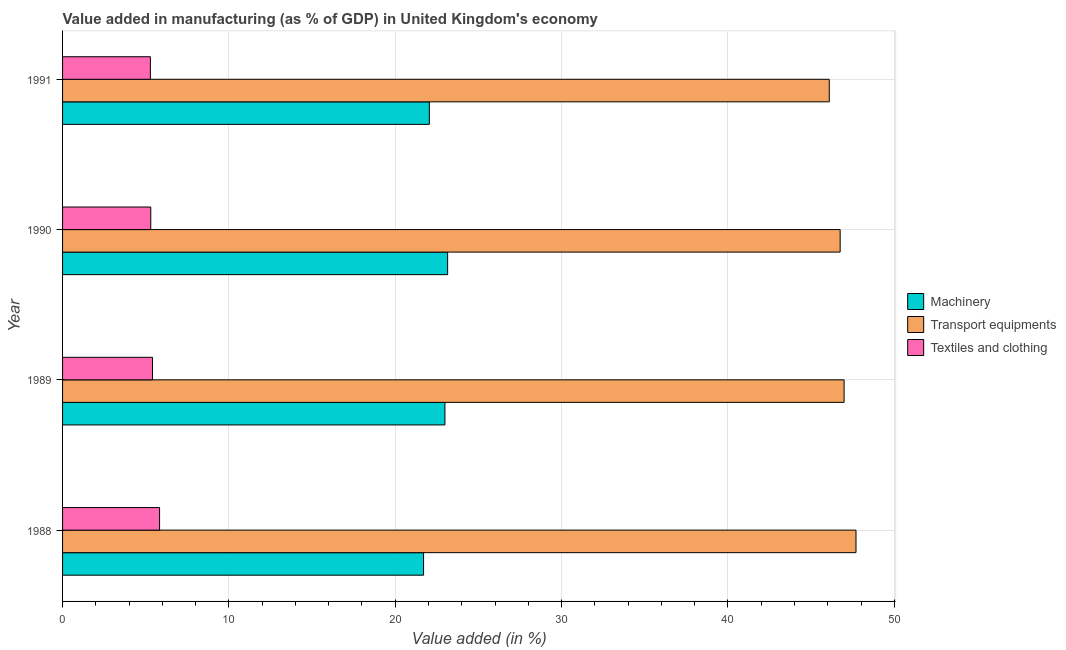How many groups of bars are there?
Offer a very short reply. 4. Are the number of bars on each tick of the Y-axis equal?
Give a very brief answer. Yes. How many bars are there on the 4th tick from the bottom?
Provide a short and direct response. 3. What is the value added in manufacturing machinery in 1988?
Your response must be concise. 21.7. Across all years, what is the maximum value added in manufacturing textile and clothing?
Make the answer very short. 5.83. Across all years, what is the minimum value added in manufacturing textile and clothing?
Offer a very short reply. 5.28. What is the total value added in manufacturing textile and clothing in the graph?
Your response must be concise. 21.82. What is the difference between the value added in manufacturing textile and clothing in 1990 and that in 1991?
Your response must be concise. 0.02. What is the difference between the value added in manufacturing transport equipments in 1991 and the value added in manufacturing machinery in 1988?
Provide a succinct answer. 24.39. What is the average value added in manufacturing machinery per year?
Provide a short and direct response. 22.47. In the year 1988, what is the difference between the value added in manufacturing machinery and value added in manufacturing transport equipments?
Provide a succinct answer. -26. What is the ratio of the value added in manufacturing textile and clothing in 1988 to that in 1991?
Your response must be concise. 1.1. Is the difference between the value added in manufacturing machinery in 1989 and 1990 greater than the difference between the value added in manufacturing transport equipments in 1989 and 1990?
Provide a short and direct response. No. What is the difference between the highest and the second highest value added in manufacturing machinery?
Give a very brief answer. 0.16. What is the difference between the highest and the lowest value added in manufacturing machinery?
Keep it short and to the point. 1.45. Is the sum of the value added in manufacturing textile and clothing in 1988 and 1989 greater than the maximum value added in manufacturing transport equipments across all years?
Provide a succinct answer. No. What does the 3rd bar from the top in 1990 represents?
Ensure brevity in your answer.  Machinery. What does the 2nd bar from the bottom in 1989 represents?
Provide a succinct answer. Transport equipments. How many legend labels are there?
Your answer should be very brief. 3. How are the legend labels stacked?
Ensure brevity in your answer.  Vertical. What is the title of the graph?
Ensure brevity in your answer.  Value added in manufacturing (as % of GDP) in United Kingdom's economy. Does "Taxes on income" appear as one of the legend labels in the graph?
Offer a very short reply. No. What is the label or title of the X-axis?
Make the answer very short. Value added (in %). What is the Value added (in %) of Machinery in 1988?
Offer a very short reply. 21.7. What is the Value added (in %) of Transport equipments in 1988?
Offer a very short reply. 47.7. What is the Value added (in %) in Textiles and clothing in 1988?
Provide a short and direct response. 5.83. What is the Value added (in %) of Machinery in 1989?
Your answer should be very brief. 22.99. What is the Value added (in %) in Transport equipments in 1989?
Give a very brief answer. 46.98. What is the Value added (in %) of Textiles and clothing in 1989?
Your answer should be compact. 5.41. What is the Value added (in %) of Machinery in 1990?
Your answer should be compact. 23.15. What is the Value added (in %) in Transport equipments in 1990?
Provide a succinct answer. 46.75. What is the Value added (in %) in Textiles and clothing in 1990?
Offer a terse response. 5.3. What is the Value added (in %) in Machinery in 1991?
Provide a short and direct response. 22.05. What is the Value added (in %) in Transport equipments in 1991?
Offer a very short reply. 46.09. What is the Value added (in %) of Textiles and clothing in 1991?
Provide a succinct answer. 5.28. Across all years, what is the maximum Value added (in %) of Machinery?
Keep it short and to the point. 23.15. Across all years, what is the maximum Value added (in %) in Transport equipments?
Make the answer very short. 47.7. Across all years, what is the maximum Value added (in %) in Textiles and clothing?
Your answer should be very brief. 5.83. Across all years, what is the minimum Value added (in %) of Machinery?
Your answer should be compact. 21.7. Across all years, what is the minimum Value added (in %) in Transport equipments?
Your answer should be very brief. 46.09. Across all years, what is the minimum Value added (in %) in Textiles and clothing?
Ensure brevity in your answer.  5.28. What is the total Value added (in %) of Machinery in the graph?
Ensure brevity in your answer.  89.89. What is the total Value added (in %) in Transport equipments in the graph?
Your response must be concise. 187.52. What is the total Value added (in %) in Textiles and clothing in the graph?
Give a very brief answer. 21.82. What is the difference between the Value added (in %) of Machinery in 1988 and that in 1989?
Provide a short and direct response. -1.28. What is the difference between the Value added (in %) of Transport equipments in 1988 and that in 1989?
Make the answer very short. 0.71. What is the difference between the Value added (in %) in Textiles and clothing in 1988 and that in 1989?
Offer a terse response. 0.42. What is the difference between the Value added (in %) in Machinery in 1988 and that in 1990?
Keep it short and to the point. -1.45. What is the difference between the Value added (in %) in Transport equipments in 1988 and that in 1990?
Your answer should be very brief. 0.95. What is the difference between the Value added (in %) of Textiles and clothing in 1988 and that in 1990?
Keep it short and to the point. 0.53. What is the difference between the Value added (in %) in Machinery in 1988 and that in 1991?
Keep it short and to the point. -0.35. What is the difference between the Value added (in %) in Transport equipments in 1988 and that in 1991?
Your response must be concise. 1.61. What is the difference between the Value added (in %) in Textiles and clothing in 1988 and that in 1991?
Offer a terse response. 0.55. What is the difference between the Value added (in %) of Machinery in 1989 and that in 1990?
Provide a short and direct response. -0.16. What is the difference between the Value added (in %) of Transport equipments in 1989 and that in 1990?
Provide a succinct answer. 0.24. What is the difference between the Value added (in %) in Textiles and clothing in 1989 and that in 1990?
Make the answer very short. 0.11. What is the difference between the Value added (in %) in Machinery in 1989 and that in 1991?
Your response must be concise. 0.94. What is the difference between the Value added (in %) in Transport equipments in 1989 and that in 1991?
Your answer should be compact. 0.89. What is the difference between the Value added (in %) in Textiles and clothing in 1989 and that in 1991?
Provide a short and direct response. 0.13. What is the difference between the Value added (in %) in Machinery in 1990 and that in 1991?
Your response must be concise. 1.1. What is the difference between the Value added (in %) of Transport equipments in 1990 and that in 1991?
Offer a very short reply. 0.65. What is the difference between the Value added (in %) in Textiles and clothing in 1990 and that in 1991?
Give a very brief answer. 0.02. What is the difference between the Value added (in %) in Machinery in 1988 and the Value added (in %) in Transport equipments in 1989?
Offer a very short reply. -25.28. What is the difference between the Value added (in %) of Machinery in 1988 and the Value added (in %) of Textiles and clothing in 1989?
Offer a terse response. 16.3. What is the difference between the Value added (in %) of Transport equipments in 1988 and the Value added (in %) of Textiles and clothing in 1989?
Offer a very short reply. 42.29. What is the difference between the Value added (in %) in Machinery in 1988 and the Value added (in %) in Transport equipments in 1990?
Provide a succinct answer. -25.04. What is the difference between the Value added (in %) of Machinery in 1988 and the Value added (in %) of Textiles and clothing in 1990?
Your answer should be very brief. 16.4. What is the difference between the Value added (in %) in Transport equipments in 1988 and the Value added (in %) in Textiles and clothing in 1990?
Offer a very short reply. 42.4. What is the difference between the Value added (in %) of Machinery in 1988 and the Value added (in %) of Transport equipments in 1991?
Give a very brief answer. -24.39. What is the difference between the Value added (in %) of Machinery in 1988 and the Value added (in %) of Textiles and clothing in 1991?
Offer a very short reply. 16.42. What is the difference between the Value added (in %) in Transport equipments in 1988 and the Value added (in %) in Textiles and clothing in 1991?
Your response must be concise. 42.42. What is the difference between the Value added (in %) in Machinery in 1989 and the Value added (in %) in Transport equipments in 1990?
Offer a terse response. -23.76. What is the difference between the Value added (in %) of Machinery in 1989 and the Value added (in %) of Textiles and clothing in 1990?
Offer a very short reply. 17.69. What is the difference between the Value added (in %) of Transport equipments in 1989 and the Value added (in %) of Textiles and clothing in 1990?
Make the answer very short. 41.68. What is the difference between the Value added (in %) of Machinery in 1989 and the Value added (in %) of Transport equipments in 1991?
Provide a succinct answer. -23.1. What is the difference between the Value added (in %) of Machinery in 1989 and the Value added (in %) of Textiles and clothing in 1991?
Keep it short and to the point. 17.71. What is the difference between the Value added (in %) in Transport equipments in 1989 and the Value added (in %) in Textiles and clothing in 1991?
Offer a very short reply. 41.71. What is the difference between the Value added (in %) of Machinery in 1990 and the Value added (in %) of Transport equipments in 1991?
Your answer should be compact. -22.94. What is the difference between the Value added (in %) in Machinery in 1990 and the Value added (in %) in Textiles and clothing in 1991?
Offer a terse response. 17.87. What is the difference between the Value added (in %) of Transport equipments in 1990 and the Value added (in %) of Textiles and clothing in 1991?
Offer a terse response. 41.47. What is the average Value added (in %) of Machinery per year?
Provide a succinct answer. 22.47. What is the average Value added (in %) in Transport equipments per year?
Provide a succinct answer. 46.88. What is the average Value added (in %) of Textiles and clothing per year?
Your answer should be compact. 5.46. In the year 1988, what is the difference between the Value added (in %) in Machinery and Value added (in %) in Transport equipments?
Offer a very short reply. -26. In the year 1988, what is the difference between the Value added (in %) of Machinery and Value added (in %) of Textiles and clothing?
Offer a terse response. 15.87. In the year 1988, what is the difference between the Value added (in %) of Transport equipments and Value added (in %) of Textiles and clothing?
Give a very brief answer. 41.87. In the year 1989, what is the difference between the Value added (in %) of Machinery and Value added (in %) of Transport equipments?
Your response must be concise. -24. In the year 1989, what is the difference between the Value added (in %) in Machinery and Value added (in %) in Textiles and clothing?
Offer a terse response. 17.58. In the year 1989, what is the difference between the Value added (in %) in Transport equipments and Value added (in %) in Textiles and clothing?
Offer a very short reply. 41.58. In the year 1990, what is the difference between the Value added (in %) of Machinery and Value added (in %) of Transport equipments?
Your answer should be compact. -23.6. In the year 1990, what is the difference between the Value added (in %) in Machinery and Value added (in %) in Textiles and clothing?
Your answer should be compact. 17.85. In the year 1990, what is the difference between the Value added (in %) in Transport equipments and Value added (in %) in Textiles and clothing?
Provide a succinct answer. 41.44. In the year 1991, what is the difference between the Value added (in %) in Machinery and Value added (in %) in Transport equipments?
Provide a short and direct response. -24.04. In the year 1991, what is the difference between the Value added (in %) of Machinery and Value added (in %) of Textiles and clothing?
Provide a short and direct response. 16.77. In the year 1991, what is the difference between the Value added (in %) of Transport equipments and Value added (in %) of Textiles and clothing?
Offer a very short reply. 40.81. What is the ratio of the Value added (in %) in Machinery in 1988 to that in 1989?
Provide a short and direct response. 0.94. What is the ratio of the Value added (in %) in Transport equipments in 1988 to that in 1989?
Offer a terse response. 1.02. What is the ratio of the Value added (in %) of Textiles and clothing in 1988 to that in 1989?
Offer a terse response. 1.08. What is the ratio of the Value added (in %) in Transport equipments in 1988 to that in 1990?
Offer a terse response. 1.02. What is the ratio of the Value added (in %) in Machinery in 1988 to that in 1991?
Make the answer very short. 0.98. What is the ratio of the Value added (in %) of Transport equipments in 1988 to that in 1991?
Offer a terse response. 1.03. What is the ratio of the Value added (in %) in Textiles and clothing in 1988 to that in 1991?
Your answer should be compact. 1.1. What is the ratio of the Value added (in %) of Machinery in 1989 to that in 1990?
Your answer should be compact. 0.99. What is the ratio of the Value added (in %) in Textiles and clothing in 1989 to that in 1990?
Provide a succinct answer. 1.02. What is the ratio of the Value added (in %) of Machinery in 1989 to that in 1991?
Ensure brevity in your answer.  1.04. What is the ratio of the Value added (in %) in Transport equipments in 1989 to that in 1991?
Offer a very short reply. 1.02. What is the ratio of the Value added (in %) of Textiles and clothing in 1989 to that in 1991?
Ensure brevity in your answer.  1.02. What is the ratio of the Value added (in %) of Machinery in 1990 to that in 1991?
Keep it short and to the point. 1.05. What is the ratio of the Value added (in %) of Transport equipments in 1990 to that in 1991?
Offer a very short reply. 1.01. What is the difference between the highest and the second highest Value added (in %) of Machinery?
Offer a very short reply. 0.16. What is the difference between the highest and the second highest Value added (in %) of Transport equipments?
Ensure brevity in your answer.  0.71. What is the difference between the highest and the second highest Value added (in %) of Textiles and clothing?
Ensure brevity in your answer.  0.42. What is the difference between the highest and the lowest Value added (in %) of Machinery?
Keep it short and to the point. 1.45. What is the difference between the highest and the lowest Value added (in %) in Transport equipments?
Your answer should be very brief. 1.61. What is the difference between the highest and the lowest Value added (in %) in Textiles and clothing?
Your answer should be compact. 0.55. 